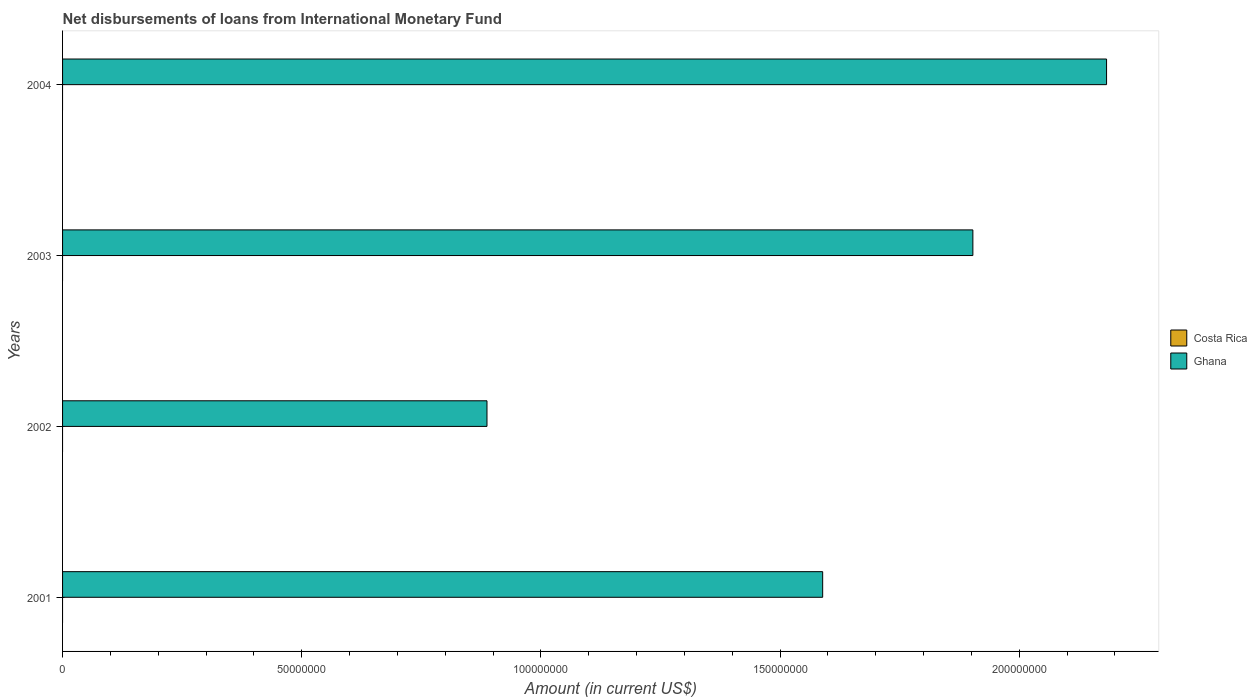How many different coloured bars are there?
Your answer should be very brief. 1. Are the number of bars per tick equal to the number of legend labels?
Offer a terse response. No. Are the number of bars on each tick of the Y-axis equal?
Keep it short and to the point. Yes. How many bars are there on the 1st tick from the top?
Your answer should be very brief. 1. How many bars are there on the 1st tick from the bottom?
Provide a succinct answer. 1. What is the label of the 2nd group of bars from the top?
Your response must be concise. 2003. In how many cases, is the number of bars for a given year not equal to the number of legend labels?
Offer a terse response. 4. What is the amount of loans disbursed in Ghana in 2004?
Your answer should be compact. 2.18e+08. Across all years, what is the maximum amount of loans disbursed in Ghana?
Make the answer very short. 2.18e+08. Across all years, what is the minimum amount of loans disbursed in Costa Rica?
Ensure brevity in your answer.  0. What is the difference between the amount of loans disbursed in Ghana in 2001 and that in 2004?
Make the answer very short. -5.93e+07. What is the difference between the amount of loans disbursed in Ghana in 2004 and the amount of loans disbursed in Costa Rica in 2003?
Give a very brief answer. 2.18e+08. What is the average amount of loans disbursed in Ghana per year?
Ensure brevity in your answer.  1.64e+08. In how many years, is the amount of loans disbursed in Costa Rica greater than 110000000 US$?
Your answer should be compact. 0. What is the ratio of the amount of loans disbursed in Ghana in 2002 to that in 2004?
Your answer should be very brief. 0.41. What is the difference between the highest and the second highest amount of loans disbursed in Ghana?
Your response must be concise. 2.79e+07. What is the difference between the highest and the lowest amount of loans disbursed in Ghana?
Give a very brief answer. 1.30e+08. In how many years, is the amount of loans disbursed in Costa Rica greater than the average amount of loans disbursed in Costa Rica taken over all years?
Provide a succinct answer. 0. Is the sum of the amount of loans disbursed in Ghana in 2001 and 2003 greater than the maximum amount of loans disbursed in Costa Rica across all years?
Keep it short and to the point. Yes. Are all the bars in the graph horizontal?
Your answer should be compact. Yes. How many years are there in the graph?
Offer a very short reply. 4. Does the graph contain grids?
Provide a short and direct response. No. Where does the legend appear in the graph?
Offer a terse response. Center right. What is the title of the graph?
Provide a succinct answer. Net disbursements of loans from International Monetary Fund. What is the label or title of the X-axis?
Make the answer very short. Amount (in current US$). What is the Amount (in current US$) of Costa Rica in 2001?
Your response must be concise. 0. What is the Amount (in current US$) in Ghana in 2001?
Make the answer very short. 1.59e+08. What is the Amount (in current US$) in Ghana in 2002?
Your answer should be compact. 8.87e+07. What is the Amount (in current US$) in Ghana in 2003?
Your answer should be compact. 1.90e+08. What is the Amount (in current US$) in Ghana in 2004?
Provide a succinct answer. 2.18e+08. Across all years, what is the maximum Amount (in current US$) in Ghana?
Provide a succinct answer. 2.18e+08. Across all years, what is the minimum Amount (in current US$) in Ghana?
Provide a succinct answer. 8.87e+07. What is the total Amount (in current US$) of Ghana in the graph?
Make the answer very short. 6.56e+08. What is the difference between the Amount (in current US$) of Ghana in 2001 and that in 2002?
Your answer should be compact. 7.02e+07. What is the difference between the Amount (in current US$) in Ghana in 2001 and that in 2003?
Offer a very short reply. -3.14e+07. What is the difference between the Amount (in current US$) of Ghana in 2001 and that in 2004?
Make the answer very short. -5.93e+07. What is the difference between the Amount (in current US$) of Ghana in 2002 and that in 2003?
Your answer should be compact. -1.02e+08. What is the difference between the Amount (in current US$) in Ghana in 2002 and that in 2004?
Your response must be concise. -1.30e+08. What is the difference between the Amount (in current US$) of Ghana in 2003 and that in 2004?
Keep it short and to the point. -2.79e+07. What is the average Amount (in current US$) of Ghana per year?
Offer a very short reply. 1.64e+08. What is the ratio of the Amount (in current US$) of Ghana in 2001 to that in 2002?
Provide a short and direct response. 1.79. What is the ratio of the Amount (in current US$) of Ghana in 2001 to that in 2003?
Offer a terse response. 0.83. What is the ratio of the Amount (in current US$) of Ghana in 2001 to that in 2004?
Your answer should be very brief. 0.73. What is the ratio of the Amount (in current US$) in Ghana in 2002 to that in 2003?
Ensure brevity in your answer.  0.47. What is the ratio of the Amount (in current US$) of Ghana in 2002 to that in 2004?
Ensure brevity in your answer.  0.41. What is the ratio of the Amount (in current US$) in Ghana in 2003 to that in 2004?
Provide a short and direct response. 0.87. What is the difference between the highest and the second highest Amount (in current US$) in Ghana?
Your answer should be compact. 2.79e+07. What is the difference between the highest and the lowest Amount (in current US$) of Ghana?
Provide a succinct answer. 1.30e+08. 